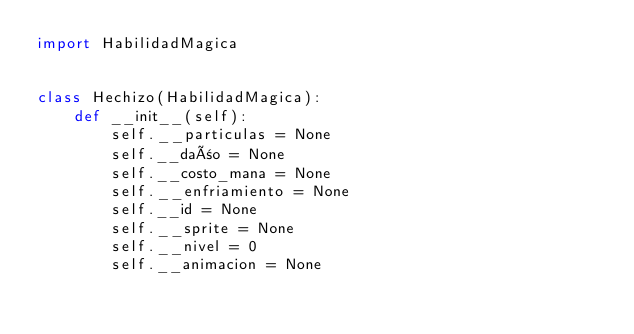<code> <loc_0><loc_0><loc_500><loc_500><_Python_>import HabilidadMagica


class Hechizo(HabilidadMagica):
    def __init__(self):
        self.__particulas = None
        self.__daño = None
        self.__costo_mana = None
        self.__enfriamiento = None
        self.__id = None
        self.__sprite = None
        self.__nivel = 0
        self.__animacion = None
</code> 